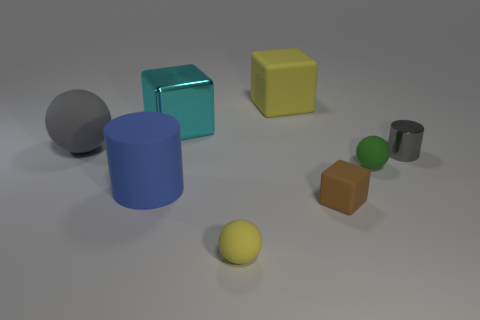Subtract all matte cubes. How many cubes are left? 1 Add 1 green shiny objects. How many objects exist? 9 Subtract all blocks. How many objects are left? 5 Subtract all green cubes. Subtract all red cylinders. How many cubes are left? 3 Add 7 small gray things. How many small gray things exist? 8 Subtract 0 yellow cylinders. How many objects are left? 8 Subtract all cyan metallic blocks. Subtract all matte balls. How many objects are left? 4 Add 1 big matte things. How many big matte things are left? 4 